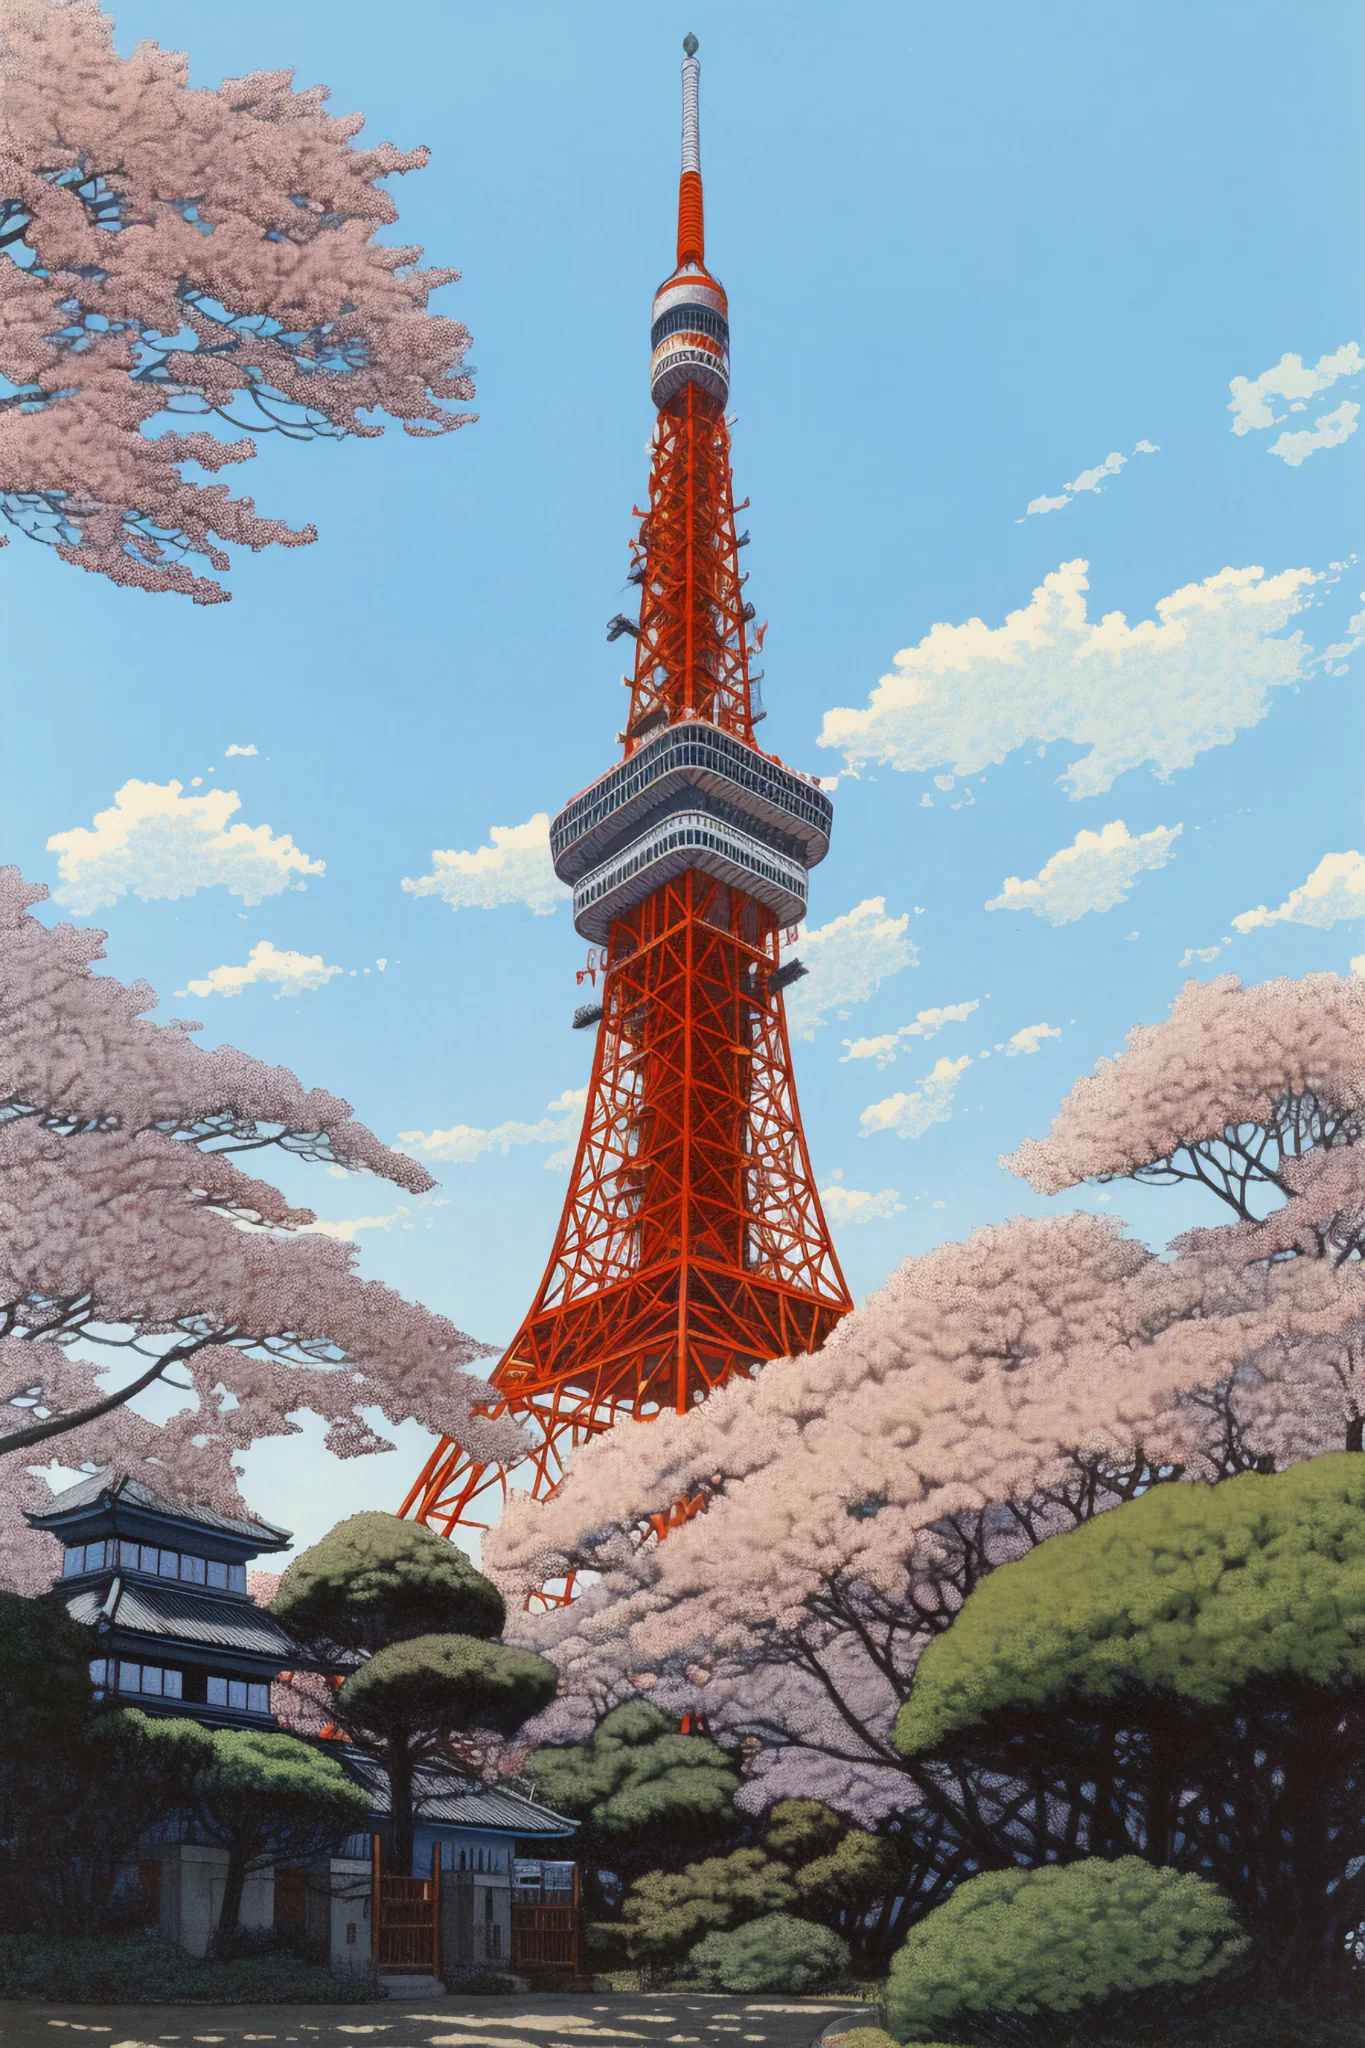How might this place appear during a grand festival? During a grand festival, Tokyo Tower and its surroundings would be a riot of colors and lights. The tower itself might be illuminated with dynamic light displays, ranging from traditional Japanese patterns to modern digital art. Colorful lanterns and streamers would adorn the cherry blossom trees, transforming the area into a lively celebration hub. Stalls offering street food, traditional crafts, and festival games would line the pathways below, filling the air with the enticing aromas of yakitori and takoyaki. There would be performances, perhaps traditional dance or taiko drumming, creating a vibrant and joyous atmosphere that continues well into the night. 